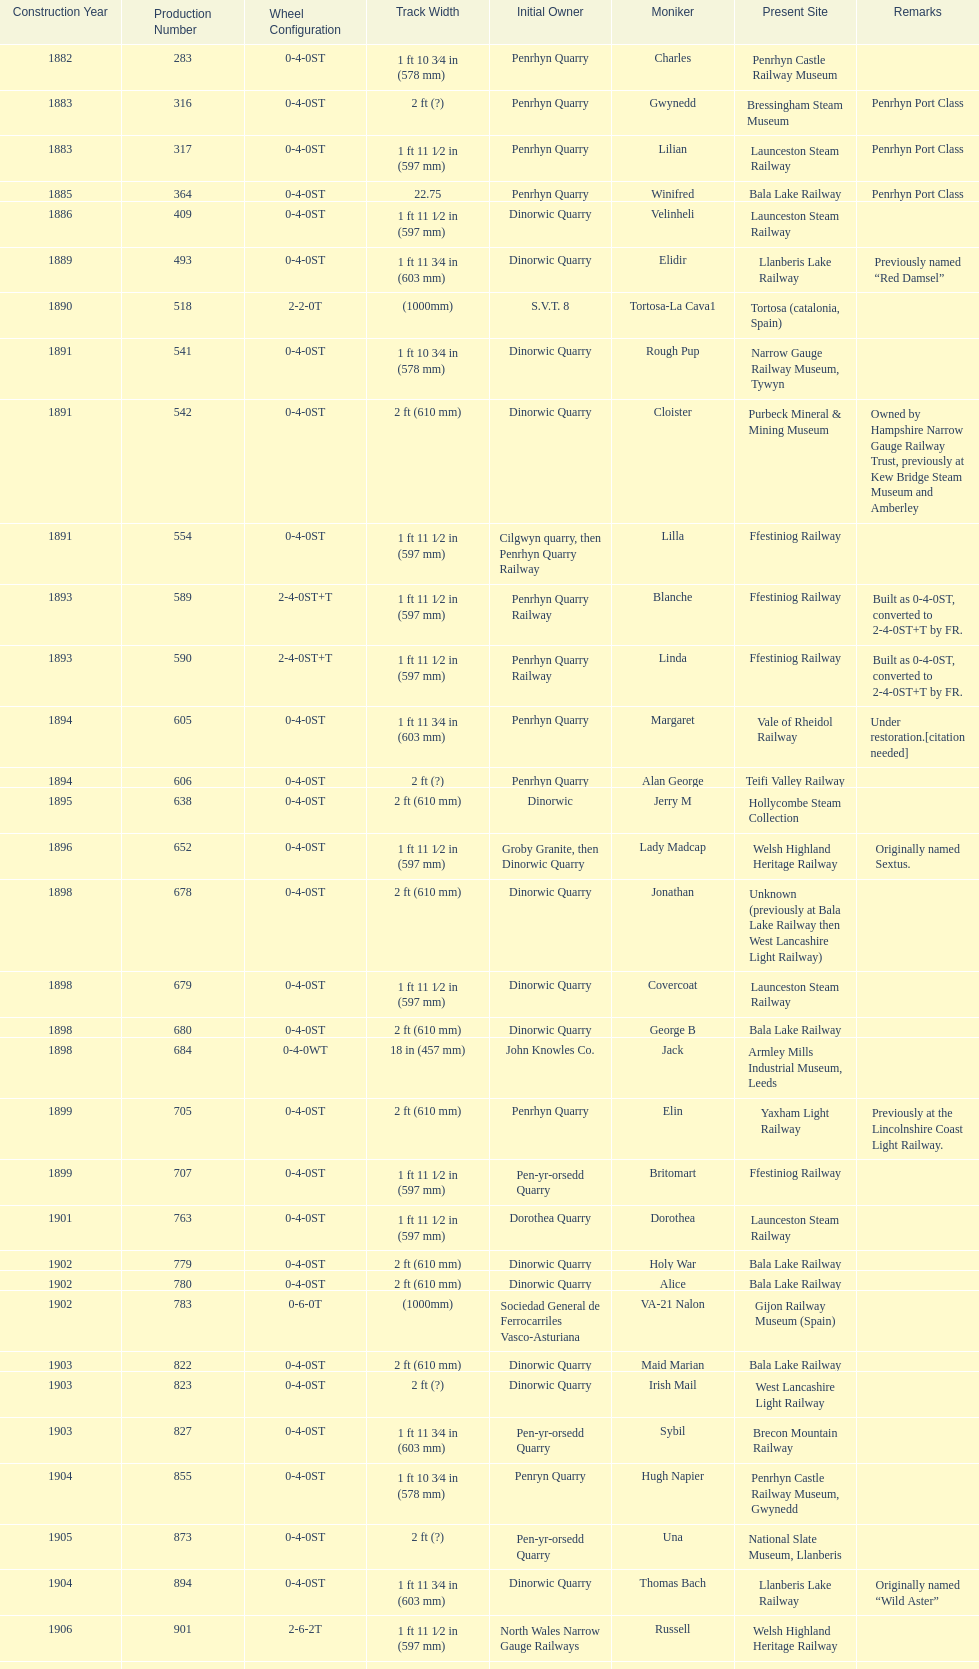Can you give me this table as a dict? {'header': ['Construction Year', 'Production Number', 'Wheel Configuration', 'Track Width', 'Initial Owner', 'Moniker', 'Present Site', 'Remarks'], 'rows': [['1882', '283', '0-4-0ST', '1\xa0ft 10\xa03⁄4\xa0in (578\xa0mm)', 'Penrhyn Quarry', 'Charles', 'Penrhyn Castle Railway Museum', ''], ['1883', '316', '0-4-0ST', '2\xa0ft (?)', 'Penrhyn Quarry', 'Gwynedd', 'Bressingham Steam Museum', 'Penrhyn Port Class'], ['1883', '317', '0-4-0ST', '1\xa0ft 11\xa01⁄2\xa0in (597\xa0mm)', 'Penrhyn Quarry', 'Lilian', 'Launceston Steam Railway', 'Penrhyn Port Class'], ['1885', '364', '0-4-0ST', '22.75', 'Penrhyn Quarry', 'Winifred', 'Bala Lake Railway', 'Penrhyn Port Class'], ['1886', '409', '0-4-0ST', '1\xa0ft 11\xa01⁄2\xa0in (597\xa0mm)', 'Dinorwic Quarry', 'Velinheli', 'Launceston Steam Railway', ''], ['1889', '493', '0-4-0ST', '1\xa0ft 11\xa03⁄4\xa0in (603\xa0mm)', 'Dinorwic Quarry', 'Elidir', 'Llanberis Lake Railway', 'Previously named “Red Damsel”'], ['1890', '518', '2-2-0T', '(1000mm)', 'S.V.T. 8', 'Tortosa-La Cava1', 'Tortosa (catalonia, Spain)', ''], ['1891', '541', '0-4-0ST', '1\xa0ft 10\xa03⁄4\xa0in (578\xa0mm)', 'Dinorwic Quarry', 'Rough Pup', 'Narrow Gauge Railway Museum, Tywyn', ''], ['1891', '542', '0-4-0ST', '2\xa0ft (610\xa0mm)', 'Dinorwic Quarry', 'Cloister', 'Purbeck Mineral & Mining Museum', 'Owned by Hampshire Narrow Gauge Railway Trust, previously at Kew Bridge Steam Museum and Amberley'], ['1891', '554', '0-4-0ST', '1\xa0ft 11\xa01⁄2\xa0in (597\xa0mm)', 'Cilgwyn quarry, then Penrhyn Quarry Railway', 'Lilla', 'Ffestiniog Railway', ''], ['1893', '589', '2-4-0ST+T', '1\xa0ft 11\xa01⁄2\xa0in (597\xa0mm)', 'Penrhyn Quarry Railway', 'Blanche', 'Ffestiniog Railway', 'Built as 0-4-0ST, converted to 2-4-0ST+T by FR.'], ['1893', '590', '2-4-0ST+T', '1\xa0ft 11\xa01⁄2\xa0in (597\xa0mm)', 'Penrhyn Quarry Railway', 'Linda', 'Ffestiniog Railway', 'Built as 0-4-0ST, converted to 2-4-0ST+T by FR.'], ['1894', '605', '0-4-0ST', '1\xa0ft 11\xa03⁄4\xa0in (603\xa0mm)', 'Penrhyn Quarry', 'Margaret', 'Vale of Rheidol Railway', 'Under restoration.[citation needed]'], ['1894', '606', '0-4-0ST', '2\xa0ft (?)', 'Penrhyn Quarry', 'Alan George', 'Teifi Valley Railway', ''], ['1895', '638', '0-4-0ST', '2\xa0ft (610\xa0mm)', 'Dinorwic', 'Jerry M', 'Hollycombe Steam Collection', ''], ['1896', '652', '0-4-0ST', '1\xa0ft 11\xa01⁄2\xa0in (597\xa0mm)', 'Groby Granite, then Dinorwic Quarry', 'Lady Madcap', 'Welsh Highland Heritage Railway', 'Originally named Sextus.'], ['1898', '678', '0-4-0ST', '2\xa0ft (610\xa0mm)', 'Dinorwic Quarry', 'Jonathan', 'Unknown (previously at Bala Lake Railway then West Lancashire Light Railway)', ''], ['1898', '679', '0-4-0ST', '1\xa0ft 11\xa01⁄2\xa0in (597\xa0mm)', 'Dinorwic Quarry', 'Covercoat', 'Launceston Steam Railway', ''], ['1898', '680', '0-4-0ST', '2\xa0ft (610\xa0mm)', 'Dinorwic Quarry', 'George B', 'Bala Lake Railway', ''], ['1898', '684', '0-4-0WT', '18\xa0in (457\xa0mm)', 'John Knowles Co.', 'Jack', 'Armley Mills Industrial Museum, Leeds', ''], ['1899', '705', '0-4-0ST', '2\xa0ft (610\xa0mm)', 'Penrhyn Quarry', 'Elin', 'Yaxham Light Railway', 'Previously at the Lincolnshire Coast Light Railway.'], ['1899', '707', '0-4-0ST', '1\xa0ft 11\xa01⁄2\xa0in (597\xa0mm)', 'Pen-yr-orsedd Quarry', 'Britomart', 'Ffestiniog Railway', ''], ['1901', '763', '0-4-0ST', '1\xa0ft 11\xa01⁄2\xa0in (597\xa0mm)', 'Dorothea Quarry', 'Dorothea', 'Launceston Steam Railway', ''], ['1902', '779', '0-4-0ST', '2\xa0ft (610\xa0mm)', 'Dinorwic Quarry', 'Holy War', 'Bala Lake Railway', ''], ['1902', '780', '0-4-0ST', '2\xa0ft (610\xa0mm)', 'Dinorwic Quarry', 'Alice', 'Bala Lake Railway', ''], ['1902', '783', '0-6-0T', '(1000mm)', 'Sociedad General de Ferrocarriles Vasco-Asturiana', 'VA-21 Nalon', 'Gijon Railway Museum (Spain)', ''], ['1903', '822', '0-4-0ST', '2\xa0ft (610\xa0mm)', 'Dinorwic Quarry', 'Maid Marian', 'Bala Lake Railway', ''], ['1903', '823', '0-4-0ST', '2\xa0ft (?)', 'Dinorwic Quarry', 'Irish Mail', 'West Lancashire Light Railway', ''], ['1903', '827', '0-4-0ST', '1\xa0ft 11\xa03⁄4\xa0in (603\xa0mm)', 'Pen-yr-orsedd Quarry', 'Sybil', 'Brecon Mountain Railway', ''], ['1904', '855', '0-4-0ST', '1\xa0ft 10\xa03⁄4\xa0in (578\xa0mm)', 'Penryn Quarry', 'Hugh Napier', 'Penrhyn Castle Railway Museum, Gwynedd', ''], ['1905', '873', '0-4-0ST', '2\xa0ft (?)', 'Pen-yr-orsedd Quarry', 'Una', 'National Slate Museum, Llanberis', ''], ['1904', '894', '0-4-0ST', '1\xa0ft 11\xa03⁄4\xa0in (603\xa0mm)', 'Dinorwic Quarry', 'Thomas Bach', 'Llanberis Lake Railway', 'Originally named “Wild Aster”'], ['1906', '901', '2-6-2T', '1\xa0ft 11\xa01⁄2\xa0in (597\xa0mm)', 'North Wales Narrow Gauge Railways', 'Russell', 'Welsh Highland Heritage Railway', ''], ['1906', '920', '0-4-0ST', '2\xa0ft (?)', 'Penrhyn Quarry', 'Pamela', 'Old Kiln Light Railway', ''], ['1909', '994', '0-4-0ST', '2\xa0ft (?)', 'Penrhyn Quarry', 'Bill Harvey', 'Bressingham Steam Museum', 'previously George Sholto'], ['1918', '1312', '4-6-0T', '1\xa0ft\xa011\xa01⁄2\xa0in (597\xa0mm)', 'British War Department\\nEFOP #203', '---', 'Pampas Safari, Gravataí, RS, Brazil', '[citation needed]'], ['1918\\nor\\n1921?', '1313', '0-6-2T', '3\xa0ft\xa03\xa03⁄8\xa0in (1,000\xa0mm)', 'British War Department\\nUsina Leão Utinga #1\\nUsina Laginha #1', '---', 'Usina Laginha, União dos Palmares, AL, Brazil', '[citation needed]'], ['1920', '1404', '0-4-0WT', '18\xa0in (457\xa0mm)', 'John Knowles Co.', 'Gwen', 'Richard Farmer current owner, Northridge, California, USA', ''], ['1922', '1429', '0-4-0ST', '2\xa0ft (610\xa0mm)', 'Dinorwic', 'Lady Joan', 'Bredgar and Wormshill Light Railway', ''], ['1922', '1430', '0-4-0ST', '1\xa0ft 11\xa03⁄4\xa0in (603\xa0mm)', 'Dinorwic Quarry', 'Dolbadarn', 'Llanberis Lake Railway', ''], ['1937', '1859', '0-4-2T', '2\xa0ft (?)', 'Umtwalumi Valley Estate, Natal', '16 Carlisle', 'South Tynedale Railway', ''], ['1940', '2075', '0-4-2T', '2\xa0ft (?)', 'Chaka’s Kraal Sugar Estates, Natal', 'Chaka’s Kraal No. 6', 'North Gloucestershire Railway', ''], ['1954', '3815', '2-6-2T', '2\xa0ft 6\xa0in (762\xa0mm)', 'Sierra Leone Government Railway', '14', 'Welshpool and Llanfair Light Railway', ''], ['1971', '3902', '0-4-2ST', '2\xa0ft (610\xa0mm)', 'Trangkil Sugar Mill, Indonesia', 'Trangkil No.4', 'Statfold Barn Railway', 'Converted from 750\xa0mm (2\xa0ft\xa05\xa01⁄2\xa0in) gauge. Last steam locomotive to be built by Hunslet, and the last industrial steam locomotive built in Britain.']]} What is the name of the last locomotive to be located at the bressingham steam museum? Gwynedd. 